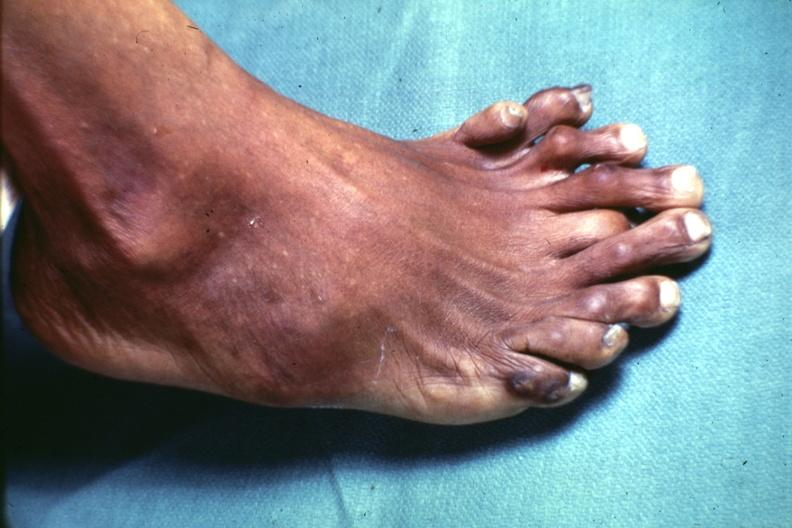does endocrine show view from dorsum of foot which has at least 9 toes?
Answer the question using a single word or phrase. No 